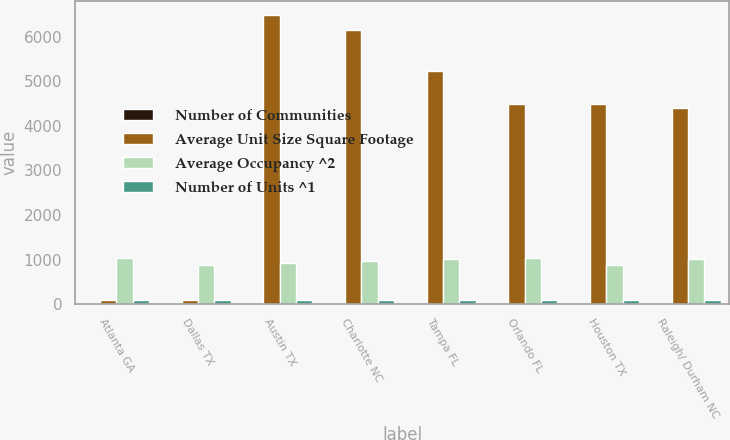Convert chart to OTSL. <chart><loc_0><loc_0><loc_500><loc_500><stacked_bar_chart><ecel><fcel>Atlanta GA<fcel>Dallas TX<fcel>Austin TX<fcel>Charlotte NC<fcel>Tampa FL<fcel>Orlando FL<fcel>Houston TX<fcel>Raleigh/ Durham NC<nl><fcel>Number of Communities<fcel>28<fcel>29<fcel>21<fcel>21<fcel>14<fcel>12<fcel>14<fcel>14<nl><fcel>Average Unit Size Square Footage<fcel>96.3<fcel>96.3<fcel>6475<fcel>6149<fcel>5220<fcel>4498<fcel>4479<fcel>4397<nl><fcel>Average Occupancy ^2<fcel>1040.4<fcel>884.2<fcel>935.6<fcel>965<fcel>1015.6<fcel>1027.4<fcel>882.4<fcel>1016.5<nl><fcel>Number of Units ^1<fcel>95.9<fcel>95.3<fcel>95.8<fcel>96.2<fcel>96.3<fcel>96.2<fcel>96.2<fcel>96.3<nl></chart> 